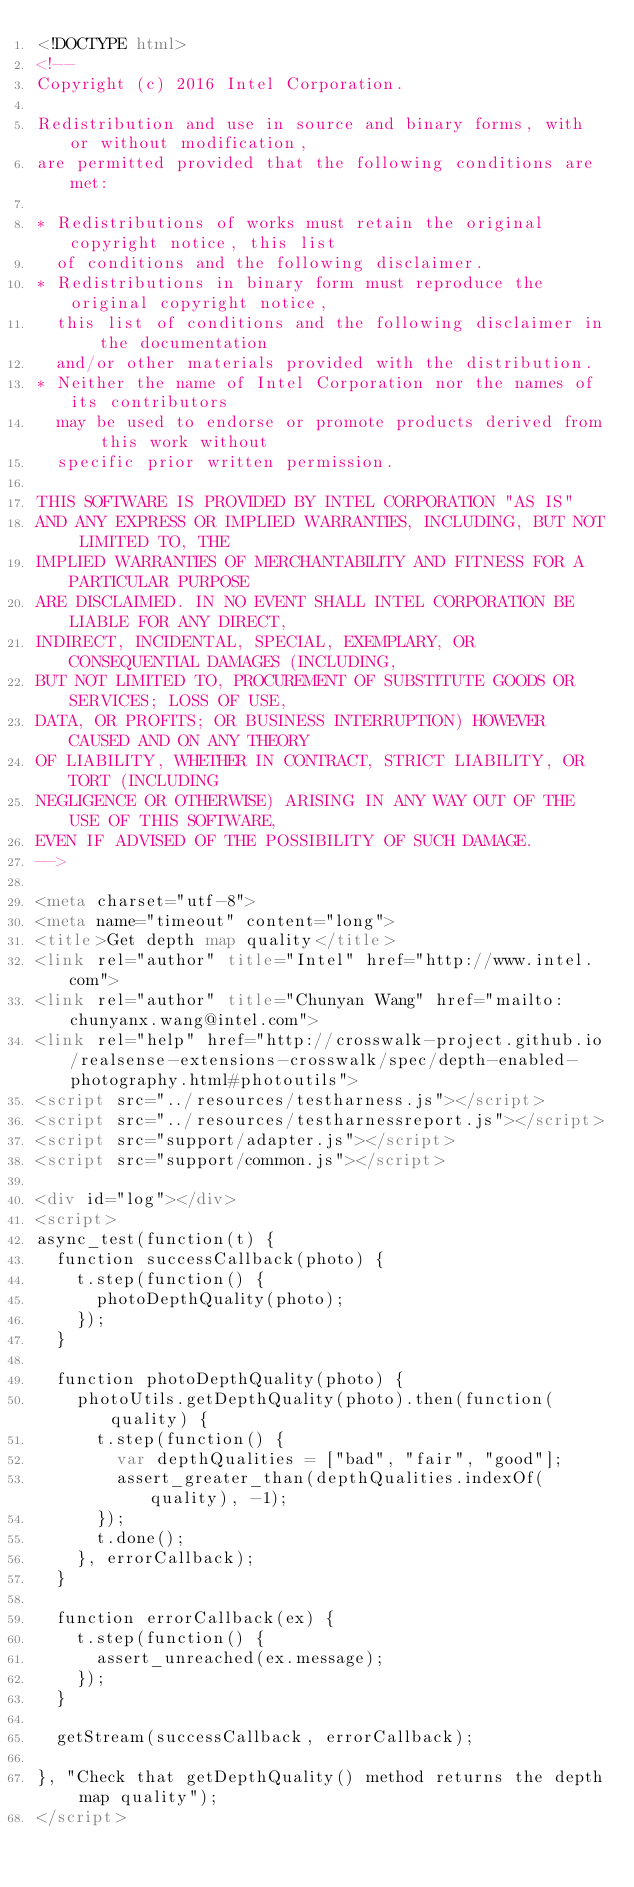Convert code to text. <code><loc_0><loc_0><loc_500><loc_500><_HTML_><!DOCTYPE html>
<!--
Copyright (c) 2016 Intel Corporation.

Redistribution and use in source and binary forms, with or without modification,
are permitted provided that the following conditions are met:

* Redistributions of works must retain the original copyright notice, this list
  of conditions and the following disclaimer.
* Redistributions in binary form must reproduce the original copyright notice,
  this list of conditions and the following disclaimer in the documentation
  and/or other materials provided with the distribution.
* Neither the name of Intel Corporation nor the names of its contributors
  may be used to endorse or promote products derived from this work without
  specific prior written permission.

THIS SOFTWARE IS PROVIDED BY INTEL CORPORATION "AS IS"
AND ANY EXPRESS OR IMPLIED WARRANTIES, INCLUDING, BUT NOT LIMITED TO, THE
IMPLIED WARRANTIES OF MERCHANTABILITY AND FITNESS FOR A PARTICULAR PURPOSE
ARE DISCLAIMED. IN NO EVENT SHALL INTEL CORPORATION BE LIABLE FOR ANY DIRECT,
INDIRECT, INCIDENTAL, SPECIAL, EXEMPLARY, OR CONSEQUENTIAL DAMAGES (INCLUDING,
BUT NOT LIMITED TO, PROCUREMENT OF SUBSTITUTE GOODS OR SERVICES; LOSS OF USE,
DATA, OR PROFITS; OR BUSINESS INTERRUPTION) HOWEVER CAUSED AND ON ANY THEORY
OF LIABILITY, WHETHER IN CONTRACT, STRICT LIABILITY, OR TORT (INCLUDING
NEGLIGENCE OR OTHERWISE) ARISING IN ANY WAY OUT OF THE USE OF THIS SOFTWARE,
EVEN IF ADVISED OF THE POSSIBILITY OF SUCH DAMAGE.
-->

<meta charset="utf-8">
<meta name="timeout" content="long">
<title>Get depth map quality</title>
<link rel="author" title="Intel" href="http://www.intel.com">
<link rel="author" title="Chunyan Wang" href="mailto:chunyanx.wang@intel.com">
<link rel="help" href="http://crosswalk-project.github.io/realsense-extensions-crosswalk/spec/depth-enabled-photography.html#photoutils">
<script src="../resources/testharness.js"></script>
<script src="../resources/testharnessreport.js"></script>
<script src="support/adapter.js"></script>
<script src="support/common.js"></script>

<div id="log"></div>
<script>
async_test(function(t) {
  function successCallback(photo) {
    t.step(function() {
      photoDepthQuality(photo);
    });
  }

  function photoDepthQuality(photo) {
    photoUtils.getDepthQuality(photo).then(function(quality) {
      t.step(function() {
        var depthQualities = ["bad", "fair", "good"];
        assert_greater_than(depthQualities.indexOf(quality), -1);
      });
      t.done();
    }, errorCallback);
  }

  function errorCallback(ex) {
    t.step(function() {
      assert_unreached(ex.message);
    });
  }

  getStream(successCallback, errorCallback);

}, "Check that getDepthQuality() method returns the depth map quality");
</script>

</code> 